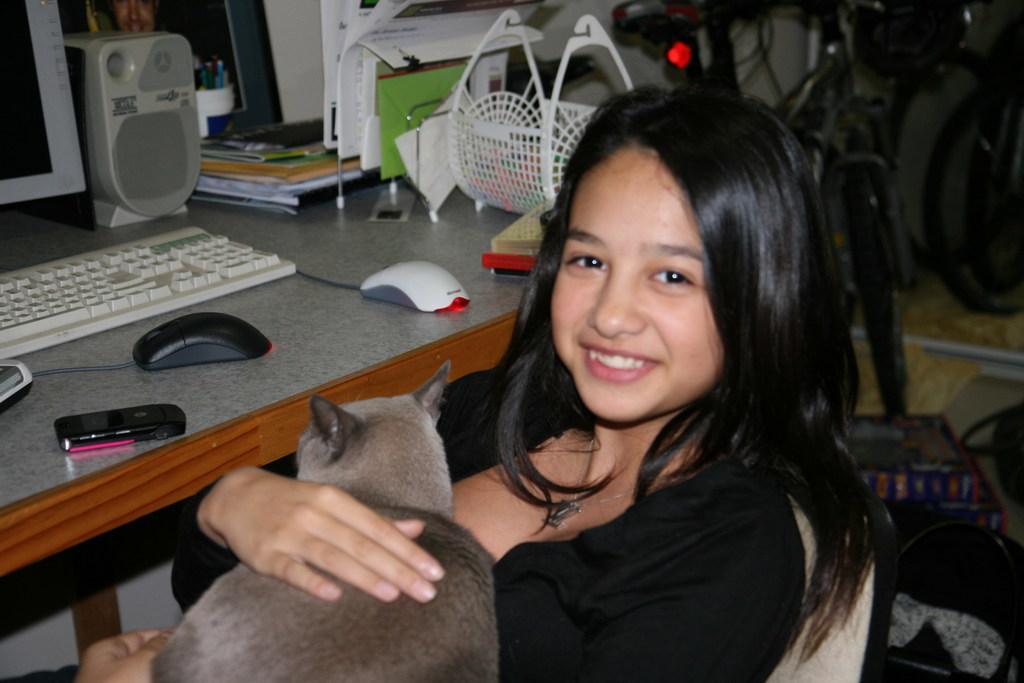Can you describe this image briefly? In a picture one woman is sitting on a chair and holding a cat and in front of her there is one table on which mouses, mobile and system with speaker and keyboard and some books and pens are present and behind her there is a one cycle. 